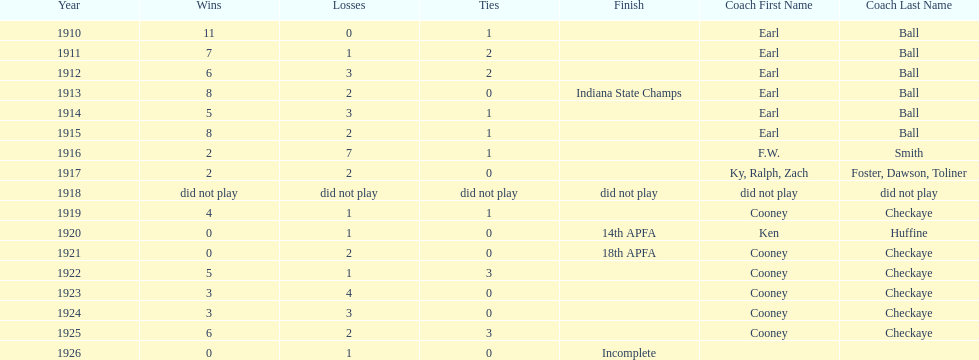The muncie flyers played from 1910 to 1925 in all but one of those years. which year did the flyers not play? 1918. 